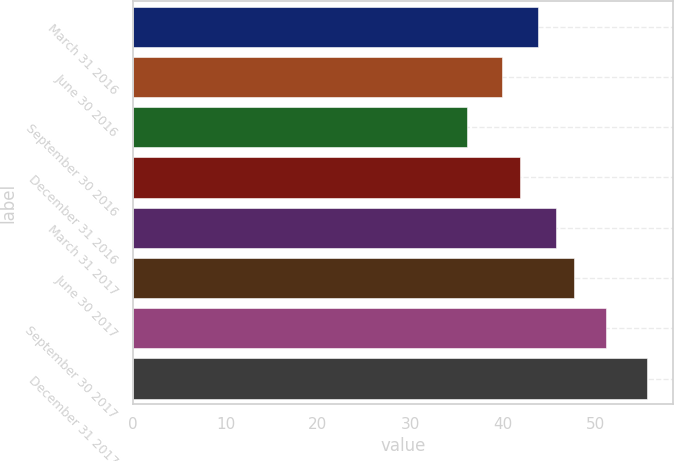Convert chart to OTSL. <chart><loc_0><loc_0><loc_500><loc_500><bar_chart><fcel>March 31 2016<fcel>June 30 2016<fcel>September 30 2016<fcel>December 31 2016<fcel>March 31 2017<fcel>June 30 2017<fcel>September 30 2017<fcel>December 31 2017<nl><fcel>43.85<fcel>39.93<fcel>36.12<fcel>41.89<fcel>45.81<fcel>47.77<fcel>51.23<fcel>55.68<nl></chart> 